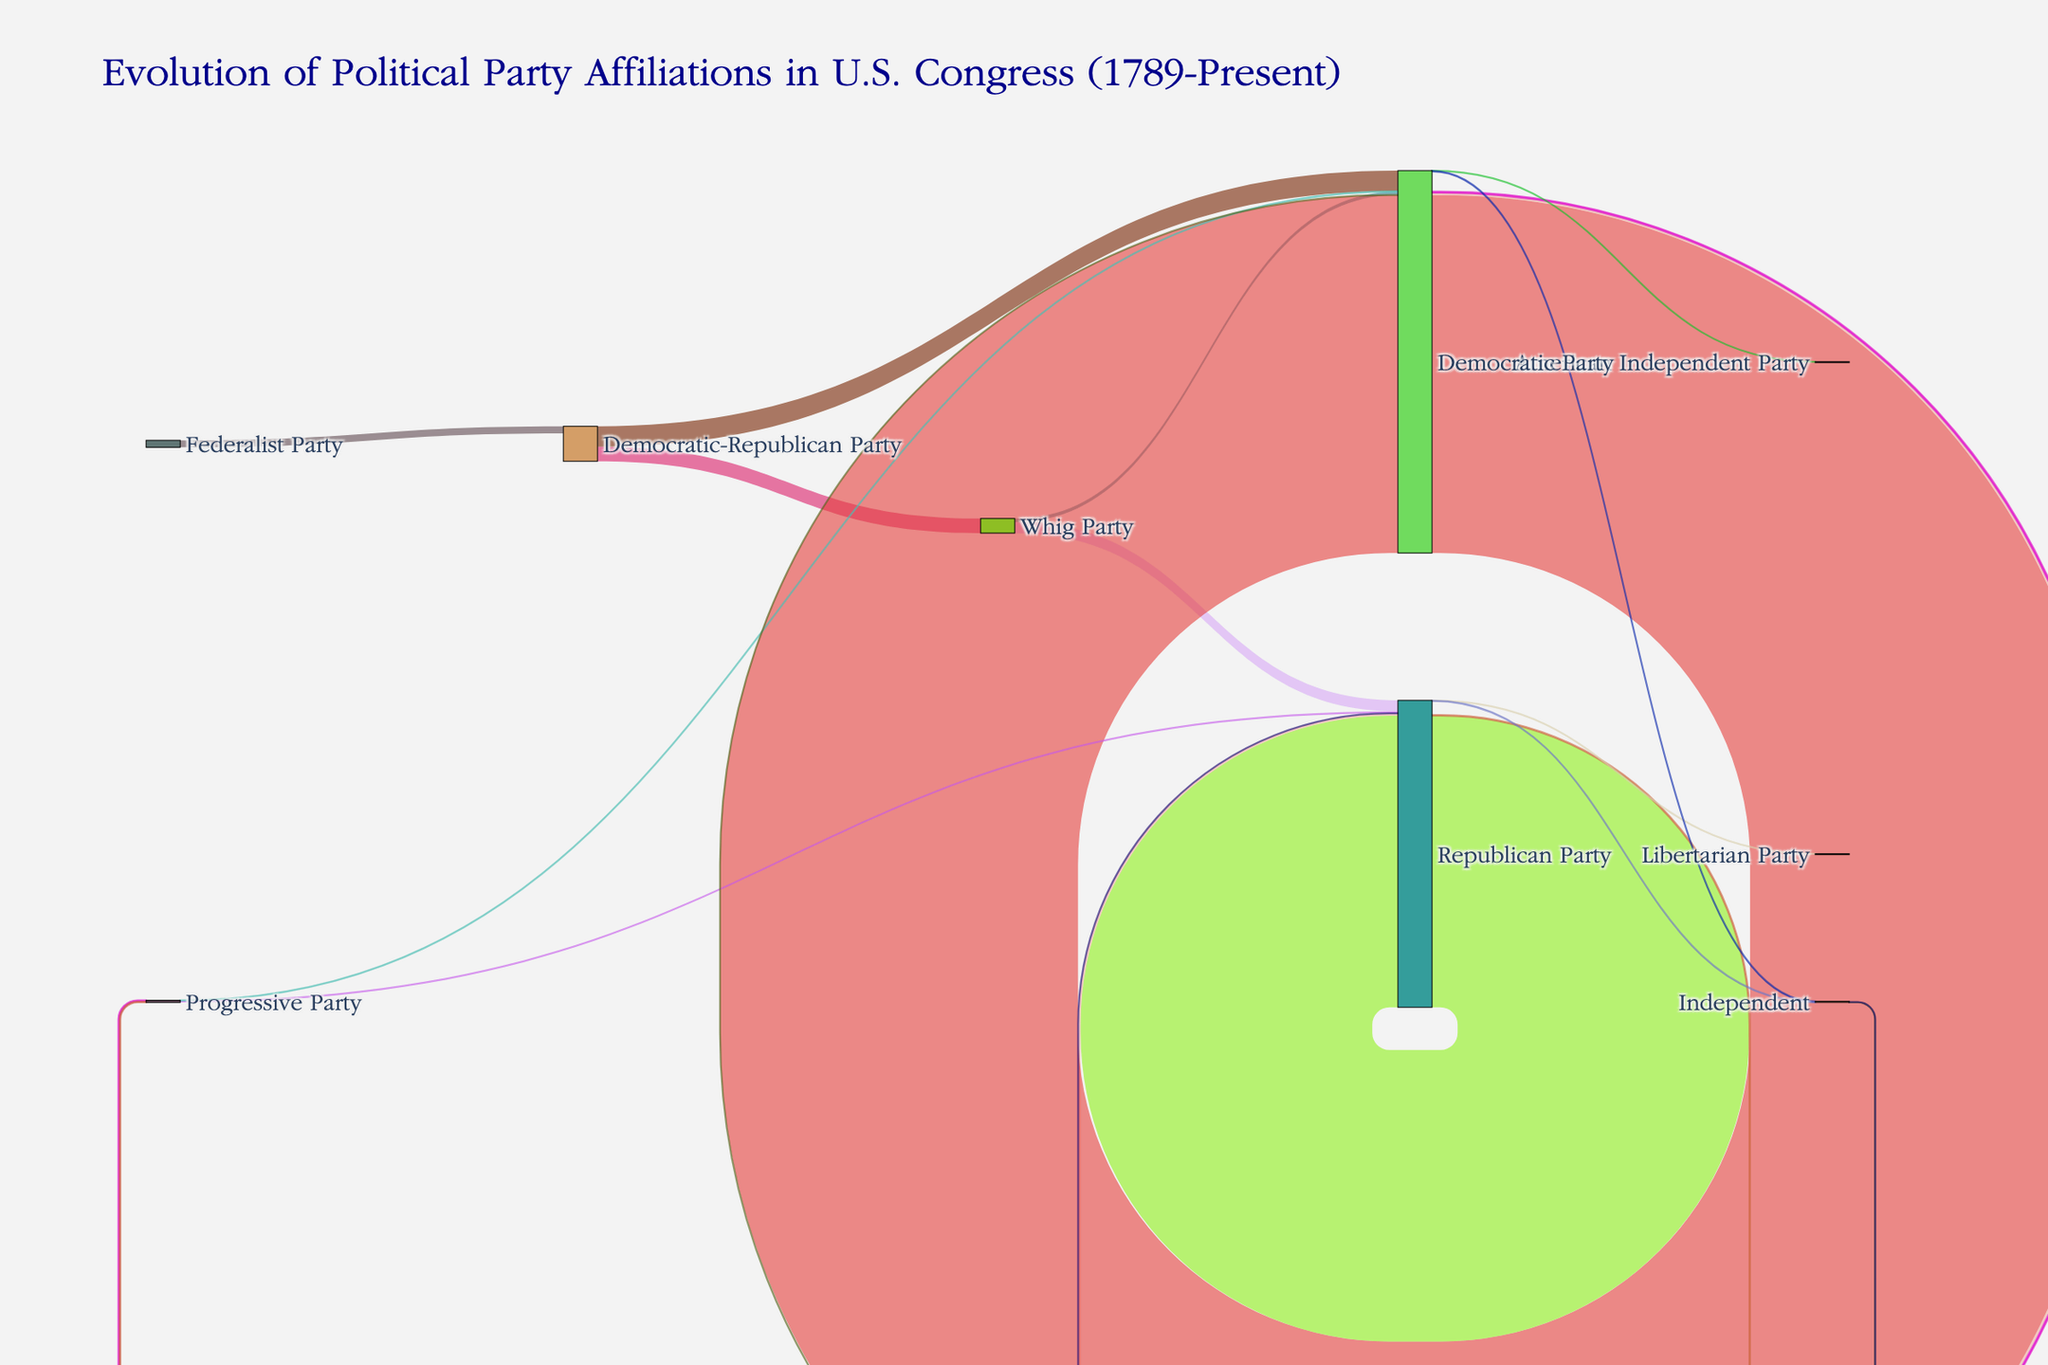what is the title of the diagram? The title is displayed at the top center of the diagram. It reads 'Evolution of Political Party Affiliations in U.S. Congress (1789-Present).'
Answer: Evolution of Political Party Affiliations in U.S. Congress (1789-Present) what color is used for the Democratic Party node? The Democratic Party's node color is displayed directly on the node itself. You can identify it by looking for the node labeled 'Democratic Party' and noting its color.
Answer: Blue how many party affiliations flow from the Federalist Party to the Democratic-Republican Party? The diagram shows a single flow from the Federalist Party to the Democratic-Republican Party, labeled with the value 35.
Answer: 35 how many political party affiliation shifts occur towards Independent? Sum the values of all the flows that have 'Independent' as the target. These flows are from the Democratic Party (3) and the Republican Party (2). So, 3 + 2 = 5.
Answer: 5 which party has the highest number of affiliations staying within the party? Look for the largest value where the source and target nodes are the same. The values are 1789 for the Democratic Party and 1458 for the Republican Party. The Democratic Party has a higher value.
Answer: Democratic Party what is the total number of shifts from the Whig Party to other parties? Add the values of all flows from the Whig Party. These flows are to the Republican Party (55) and the Democratic Party (18). So, 55 + 18 = 73.
Answer: 73 which party affiliation shift has the lowest value? Identify the minimum value in the list of flows. The values are given and the smallest one is from the Democratic Party to the American Independent Party with a value of 1.
Answer: Democratic Party to American Independent Party which political party had transitions to both the Democratic and Republican Parties? Look for a source node that has flows towards both the Democratic and the Republican parties. The Whig Party has such transitions with values of 18 and 55 respectively.
Answer: Whig Party what is the total number of flows involving the Progressive Party? Sum all the flows that either originate from or go to the Progressive Party. The flows are: Democratic Party to Progressive Party (7), Republican Party to Progressive Party (4), Progressive Party to Republican Party (9), and Progressive Party to Democratic Party (2). So, 7 + 4 + 9 + 2 = 22.
Answer: 22 how many more affiliations does the Democratic Party retain within itself compared to the Republican Party retaining within itself? Compare the internal retention values of both parties. The Democratic Party retains 1789 affiliations and the Republican Party retains 1458 affiliations. Subtract the latter from the former: 1789 - 1458 = 331.
Answer: 331 